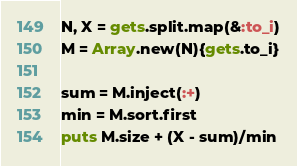<code> <loc_0><loc_0><loc_500><loc_500><_Ruby_>N, X = gets.split.map(&:to_i)
M = Array.new(N){gets.to_i}

sum = M.inject(:+)
min = M.sort.first
puts M.size + (X - sum)/min</code> 